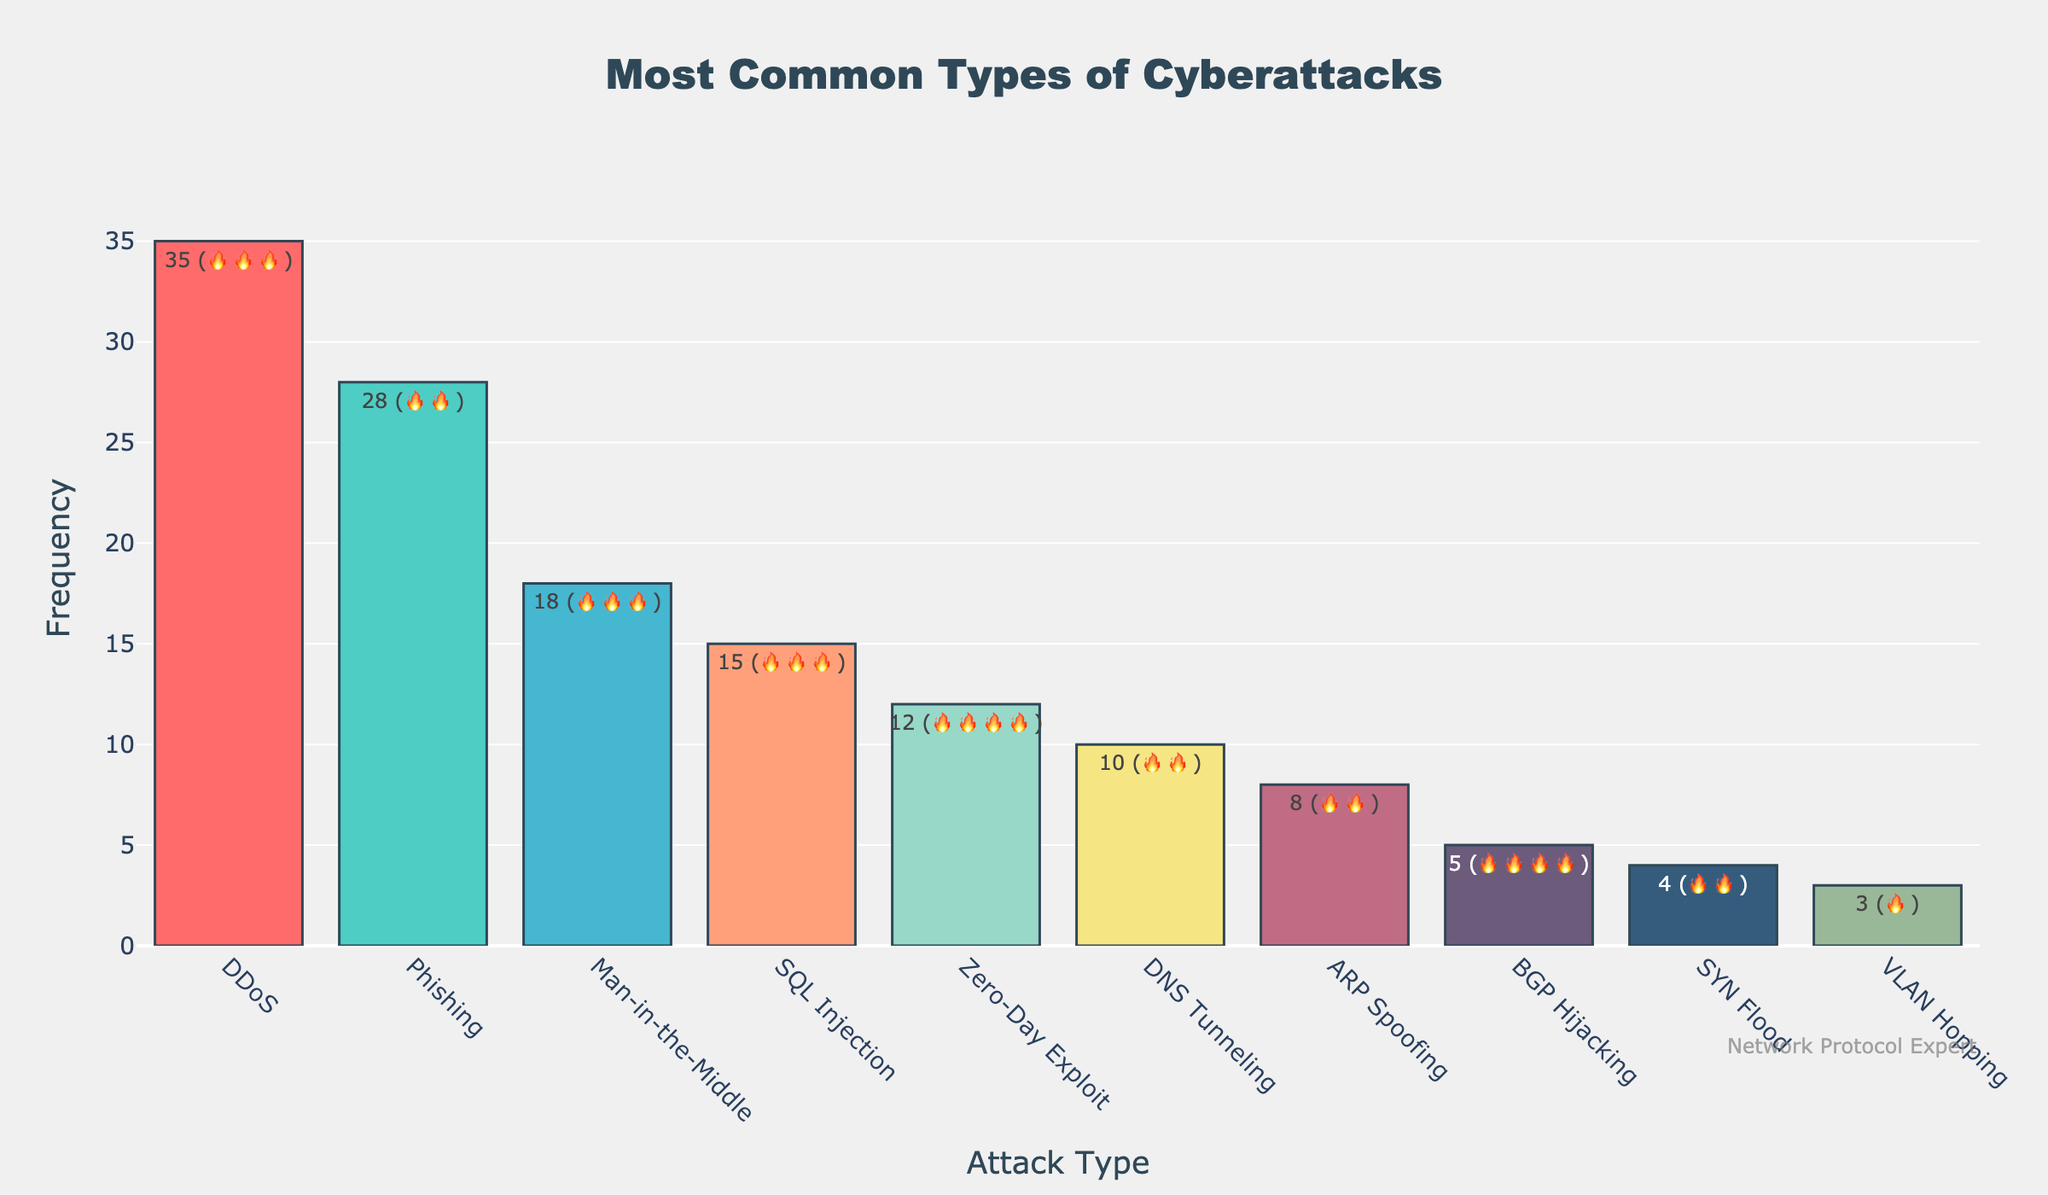What is the title of the figure? The title is displayed at the top of the figure, indicating the topic being visualized.
Answer: Most Common Types of Cyberattacks Which attack type has the highest frequency? The bar that reaches the highest point on the y-axis represents the attack type with the highest frequency.
Answer: DDoS How many attack types have a threat level of 🔥🔥🔥🔥? Count the text annotations or hover text information for the threat level emoji 🔥🔥🔥🔥.
Answer: 2 What is the combined frequency of Phishing and DNS Tunneling attacks? Find the frequencies for Phishing (28) and DNS Tunneling (10) and sum them up.
Answer: 38 Which attack type has a lower frequency: SQL Injection or Man-in-the-Middle? Compare the heights of the bars for SQL Injection and Man-in-the-Middle.
Answer: SQL Injection What is the total number of attack types shown in the figure? Count the number of bars on the x-axis, which represent different attack types.
Answer: 10 Which attack type has a higher threat level: ARP Spoofing or VLAN Hopping? Check the threat level text annotations or hover text for both ARP Spoofing and VLAN Hopping.
Answer: ARP Spoofing 